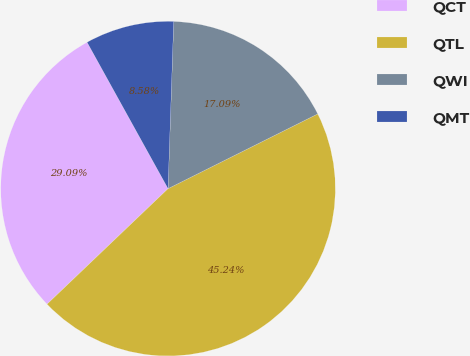Convert chart. <chart><loc_0><loc_0><loc_500><loc_500><pie_chart><fcel>QCT<fcel>QTL<fcel>QWI<fcel>QMT<nl><fcel>29.09%<fcel>45.24%<fcel>17.09%<fcel>8.58%<nl></chart> 